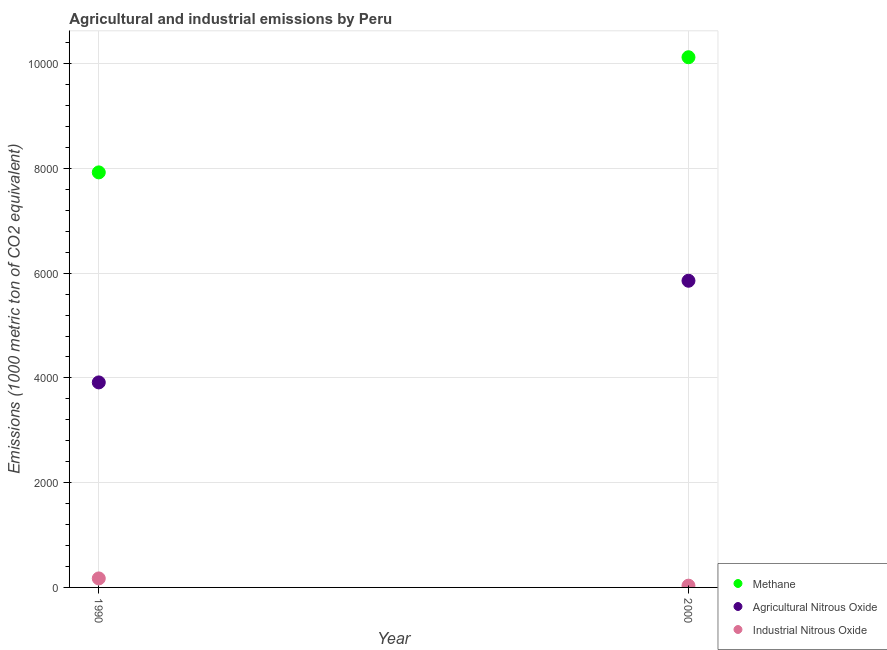Is the number of dotlines equal to the number of legend labels?
Provide a succinct answer. Yes. What is the amount of agricultural nitrous oxide emissions in 1990?
Your answer should be very brief. 3914.1. Across all years, what is the maximum amount of methane emissions?
Offer a very short reply. 1.01e+04. Across all years, what is the minimum amount of methane emissions?
Your answer should be very brief. 7923.7. In which year was the amount of methane emissions maximum?
Your response must be concise. 2000. What is the total amount of industrial nitrous oxide emissions in the graph?
Offer a very short reply. 205.4. What is the difference between the amount of agricultural nitrous oxide emissions in 1990 and that in 2000?
Your answer should be compact. -1940.8. What is the difference between the amount of agricultural nitrous oxide emissions in 1990 and the amount of methane emissions in 2000?
Your response must be concise. -6207.8. What is the average amount of industrial nitrous oxide emissions per year?
Your answer should be compact. 102.7. In the year 2000, what is the difference between the amount of agricultural nitrous oxide emissions and amount of methane emissions?
Ensure brevity in your answer.  -4267. What is the ratio of the amount of industrial nitrous oxide emissions in 1990 to that in 2000?
Ensure brevity in your answer.  5.13. In how many years, is the amount of industrial nitrous oxide emissions greater than the average amount of industrial nitrous oxide emissions taken over all years?
Make the answer very short. 1. Is it the case that in every year, the sum of the amount of methane emissions and amount of agricultural nitrous oxide emissions is greater than the amount of industrial nitrous oxide emissions?
Provide a short and direct response. Yes. Does the amount of methane emissions monotonically increase over the years?
Provide a succinct answer. Yes. How many dotlines are there?
Ensure brevity in your answer.  3. How many years are there in the graph?
Provide a short and direct response. 2. What is the difference between two consecutive major ticks on the Y-axis?
Your answer should be compact. 2000. Are the values on the major ticks of Y-axis written in scientific E-notation?
Provide a succinct answer. No. How many legend labels are there?
Offer a terse response. 3. What is the title of the graph?
Offer a terse response. Agricultural and industrial emissions by Peru. Does "Private sector" appear as one of the legend labels in the graph?
Make the answer very short. No. What is the label or title of the Y-axis?
Your answer should be compact. Emissions (1000 metric ton of CO2 equivalent). What is the Emissions (1000 metric ton of CO2 equivalent) of Methane in 1990?
Your answer should be compact. 7923.7. What is the Emissions (1000 metric ton of CO2 equivalent) in Agricultural Nitrous Oxide in 1990?
Provide a succinct answer. 3914.1. What is the Emissions (1000 metric ton of CO2 equivalent) of Industrial Nitrous Oxide in 1990?
Give a very brief answer. 171.9. What is the Emissions (1000 metric ton of CO2 equivalent) of Methane in 2000?
Your answer should be very brief. 1.01e+04. What is the Emissions (1000 metric ton of CO2 equivalent) of Agricultural Nitrous Oxide in 2000?
Your answer should be compact. 5854.9. What is the Emissions (1000 metric ton of CO2 equivalent) of Industrial Nitrous Oxide in 2000?
Provide a short and direct response. 33.5. Across all years, what is the maximum Emissions (1000 metric ton of CO2 equivalent) in Methane?
Give a very brief answer. 1.01e+04. Across all years, what is the maximum Emissions (1000 metric ton of CO2 equivalent) of Agricultural Nitrous Oxide?
Your response must be concise. 5854.9. Across all years, what is the maximum Emissions (1000 metric ton of CO2 equivalent) in Industrial Nitrous Oxide?
Make the answer very short. 171.9. Across all years, what is the minimum Emissions (1000 metric ton of CO2 equivalent) in Methane?
Offer a very short reply. 7923.7. Across all years, what is the minimum Emissions (1000 metric ton of CO2 equivalent) of Agricultural Nitrous Oxide?
Give a very brief answer. 3914.1. Across all years, what is the minimum Emissions (1000 metric ton of CO2 equivalent) of Industrial Nitrous Oxide?
Provide a succinct answer. 33.5. What is the total Emissions (1000 metric ton of CO2 equivalent) of Methane in the graph?
Ensure brevity in your answer.  1.80e+04. What is the total Emissions (1000 metric ton of CO2 equivalent) in Agricultural Nitrous Oxide in the graph?
Ensure brevity in your answer.  9769. What is the total Emissions (1000 metric ton of CO2 equivalent) in Industrial Nitrous Oxide in the graph?
Your answer should be very brief. 205.4. What is the difference between the Emissions (1000 metric ton of CO2 equivalent) of Methane in 1990 and that in 2000?
Your answer should be compact. -2198.2. What is the difference between the Emissions (1000 metric ton of CO2 equivalent) in Agricultural Nitrous Oxide in 1990 and that in 2000?
Your response must be concise. -1940.8. What is the difference between the Emissions (1000 metric ton of CO2 equivalent) in Industrial Nitrous Oxide in 1990 and that in 2000?
Provide a succinct answer. 138.4. What is the difference between the Emissions (1000 metric ton of CO2 equivalent) in Methane in 1990 and the Emissions (1000 metric ton of CO2 equivalent) in Agricultural Nitrous Oxide in 2000?
Provide a short and direct response. 2068.8. What is the difference between the Emissions (1000 metric ton of CO2 equivalent) of Methane in 1990 and the Emissions (1000 metric ton of CO2 equivalent) of Industrial Nitrous Oxide in 2000?
Provide a succinct answer. 7890.2. What is the difference between the Emissions (1000 metric ton of CO2 equivalent) of Agricultural Nitrous Oxide in 1990 and the Emissions (1000 metric ton of CO2 equivalent) of Industrial Nitrous Oxide in 2000?
Offer a very short reply. 3880.6. What is the average Emissions (1000 metric ton of CO2 equivalent) in Methane per year?
Your response must be concise. 9022.8. What is the average Emissions (1000 metric ton of CO2 equivalent) of Agricultural Nitrous Oxide per year?
Keep it short and to the point. 4884.5. What is the average Emissions (1000 metric ton of CO2 equivalent) of Industrial Nitrous Oxide per year?
Provide a succinct answer. 102.7. In the year 1990, what is the difference between the Emissions (1000 metric ton of CO2 equivalent) in Methane and Emissions (1000 metric ton of CO2 equivalent) in Agricultural Nitrous Oxide?
Provide a succinct answer. 4009.6. In the year 1990, what is the difference between the Emissions (1000 metric ton of CO2 equivalent) in Methane and Emissions (1000 metric ton of CO2 equivalent) in Industrial Nitrous Oxide?
Ensure brevity in your answer.  7751.8. In the year 1990, what is the difference between the Emissions (1000 metric ton of CO2 equivalent) in Agricultural Nitrous Oxide and Emissions (1000 metric ton of CO2 equivalent) in Industrial Nitrous Oxide?
Provide a succinct answer. 3742.2. In the year 2000, what is the difference between the Emissions (1000 metric ton of CO2 equivalent) in Methane and Emissions (1000 metric ton of CO2 equivalent) in Agricultural Nitrous Oxide?
Your answer should be compact. 4267. In the year 2000, what is the difference between the Emissions (1000 metric ton of CO2 equivalent) in Methane and Emissions (1000 metric ton of CO2 equivalent) in Industrial Nitrous Oxide?
Provide a succinct answer. 1.01e+04. In the year 2000, what is the difference between the Emissions (1000 metric ton of CO2 equivalent) of Agricultural Nitrous Oxide and Emissions (1000 metric ton of CO2 equivalent) of Industrial Nitrous Oxide?
Keep it short and to the point. 5821.4. What is the ratio of the Emissions (1000 metric ton of CO2 equivalent) in Methane in 1990 to that in 2000?
Offer a very short reply. 0.78. What is the ratio of the Emissions (1000 metric ton of CO2 equivalent) in Agricultural Nitrous Oxide in 1990 to that in 2000?
Your answer should be compact. 0.67. What is the ratio of the Emissions (1000 metric ton of CO2 equivalent) of Industrial Nitrous Oxide in 1990 to that in 2000?
Ensure brevity in your answer.  5.13. What is the difference between the highest and the second highest Emissions (1000 metric ton of CO2 equivalent) in Methane?
Provide a succinct answer. 2198.2. What is the difference between the highest and the second highest Emissions (1000 metric ton of CO2 equivalent) in Agricultural Nitrous Oxide?
Give a very brief answer. 1940.8. What is the difference between the highest and the second highest Emissions (1000 metric ton of CO2 equivalent) of Industrial Nitrous Oxide?
Keep it short and to the point. 138.4. What is the difference between the highest and the lowest Emissions (1000 metric ton of CO2 equivalent) in Methane?
Your response must be concise. 2198.2. What is the difference between the highest and the lowest Emissions (1000 metric ton of CO2 equivalent) in Agricultural Nitrous Oxide?
Your answer should be compact. 1940.8. What is the difference between the highest and the lowest Emissions (1000 metric ton of CO2 equivalent) of Industrial Nitrous Oxide?
Keep it short and to the point. 138.4. 